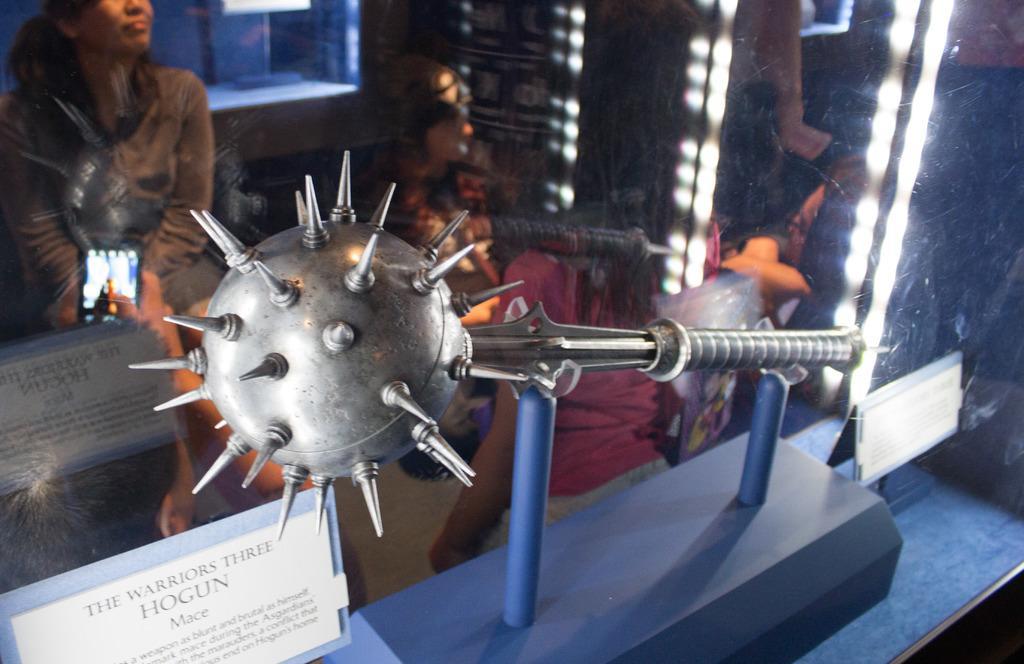In one or two sentences, can you explain what this image depicts? In this image in the foreground there is a weapon, and there are some boards and in the center there is a glass door and through the door we could see a reflection of some people, lights, window, wall and some objects. And at the bottom of the image there is table. 